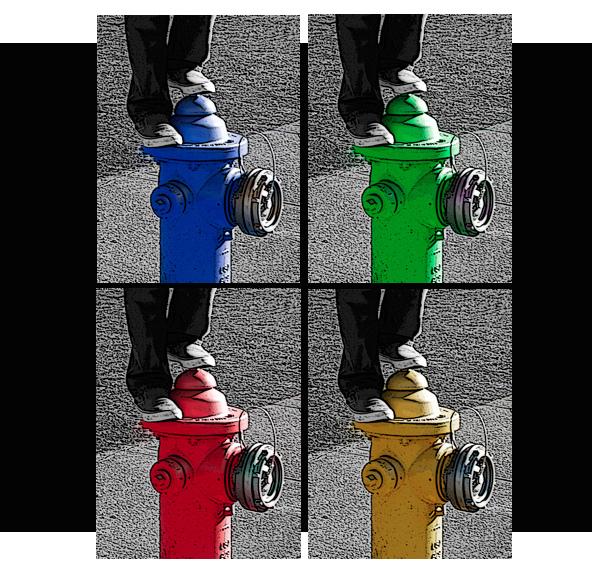How many different colors are the hydrants?
Write a very short answer. 4. What color is top right hydrant?
Be succinct. Green. Is someone standing on the hydrant?
Give a very brief answer. Yes. 